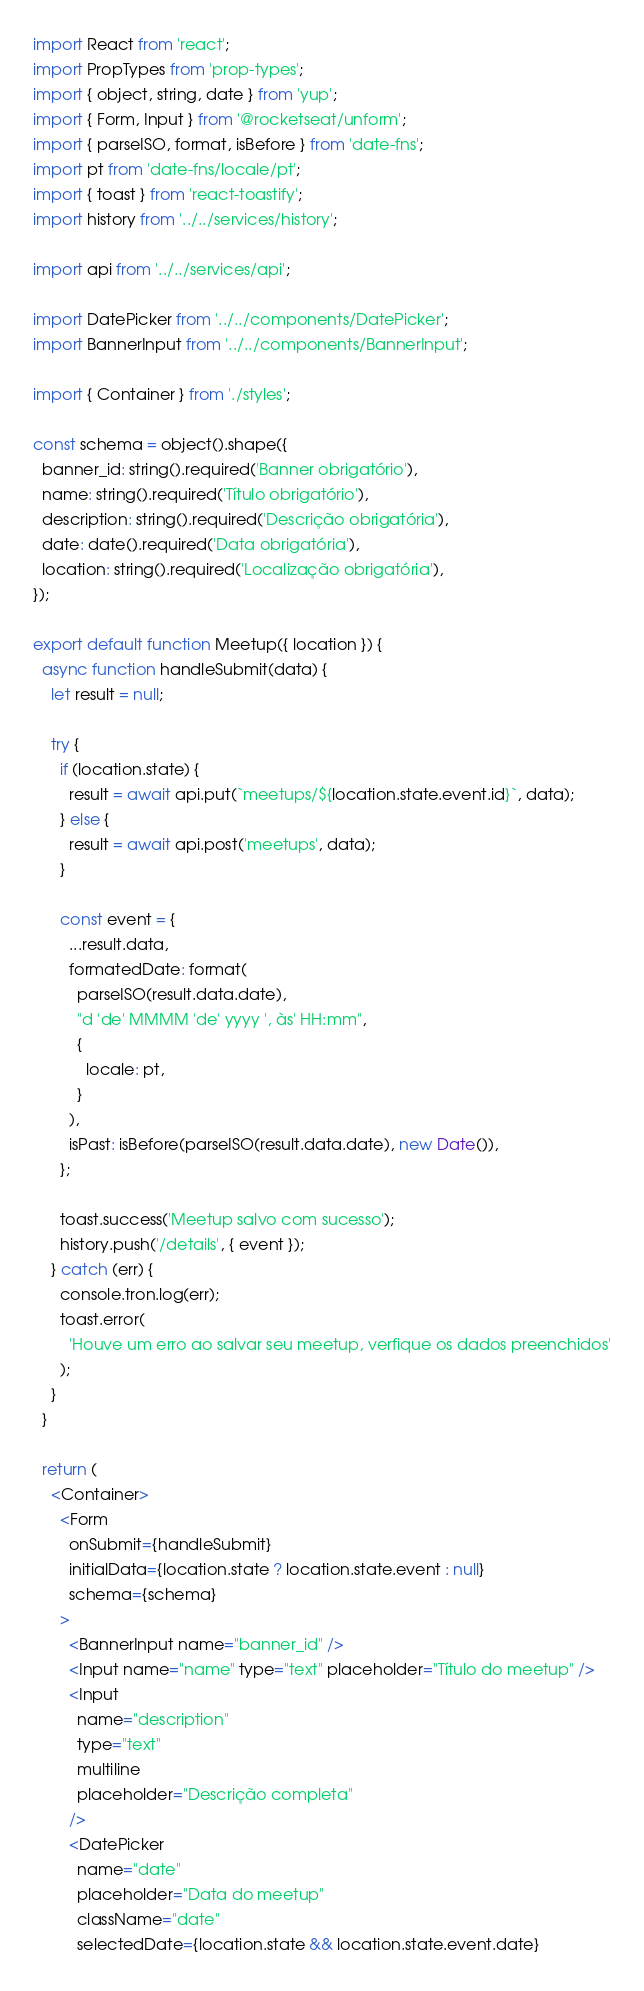<code> <loc_0><loc_0><loc_500><loc_500><_JavaScript_>import React from 'react';
import PropTypes from 'prop-types';
import { object, string, date } from 'yup';
import { Form, Input } from '@rocketseat/unform';
import { parseISO, format, isBefore } from 'date-fns';
import pt from 'date-fns/locale/pt';
import { toast } from 'react-toastify';
import history from '../../services/history';

import api from '../../services/api';

import DatePicker from '../../components/DatePicker';
import BannerInput from '../../components/BannerInput';

import { Container } from './styles';

const schema = object().shape({
  banner_id: string().required('Banner obrigatório'),
  name: string().required('Título obrigatório'),
  description: string().required('Descrição obrigatória'),
  date: date().required('Data obrigatória'),
  location: string().required('Localização obrigatória'),
});

export default function Meetup({ location }) {
  async function handleSubmit(data) {
    let result = null;

    try {
      if (location.state) {
        result = await api.put(`meetups/${location.state.event.id}`, data);
      } else {
        result = await api.post('meetups', data);
      }

      const event = {
        ...result.data,
        formatedDate: format(
          parseISO(result.data.date),
          "d 'de' MMMM 'de' yyyy ', às' HH:mm",
          {
            locale: pt,
          }
        ),
        isPast: isBefore(parseISO(result.data.date), new Date()),
      };

      toast.success('Meetup salvo com sucesso');
      history.push('/details', { event });
    } catch (err) {
      console.tron.log(err);
      toast.error(
        'Houve um erro ao salvar seu meetup, verfique os dados preenchidos'
      );
    }
  }

  return (
    <Container>
      <Form
        onSubmit={handleSubmit}
        initialData={location.state ? location.state.event : null}
        schema={schema}
      >
        <BannerInput name="banner_id" />
        <Input name="name" type="text" placeholder="Título do meetup" />
        <Input
          name="description"
          type="text"
          multiline
          placeholder="Descrição completa"
        />
        <DatePicker
          name="date"
          placeholder="Data do meetup"
          className="date"
          selectedDate={location.state && location.state.event.date}</code> 